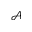Convert formula to latex. <formula><loc_0><loc_0><loc_500><loc_500>\mathcal { A }</formula> 